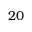Convert formula to latex. <formula><loc_0><loc_0><loc_500><loc_500>2 0</formula> 